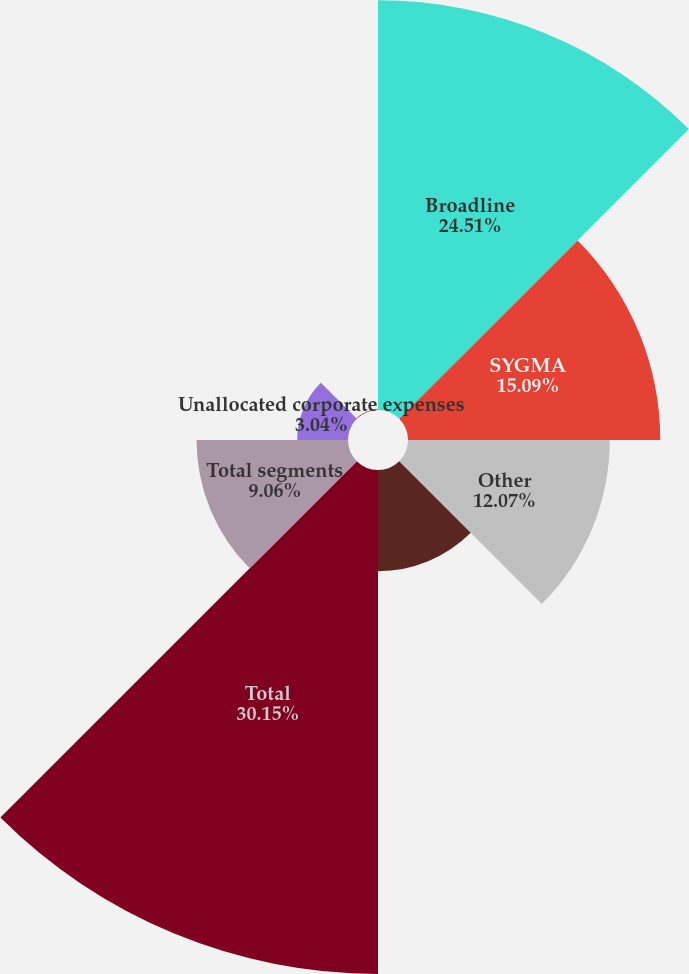Convert chart. <chart><loc_0><loc_0><loc_500><loc_500><pie_chart><fcel>Broadline<fcel>SYGMA<fcel>Other<fcel>Intersegment sales<fcel>Total<fcel>Total segments<fcel>Unallocated corporate expenses<fcel>Corporate<nl><fcel>24.51%<fcel>15.09%<fcel>12.07%<fcel>6.05%<fcel>30.15%<fcel>9.06%<fcel>3.04%<fcel>0.03%<nl></chart> 